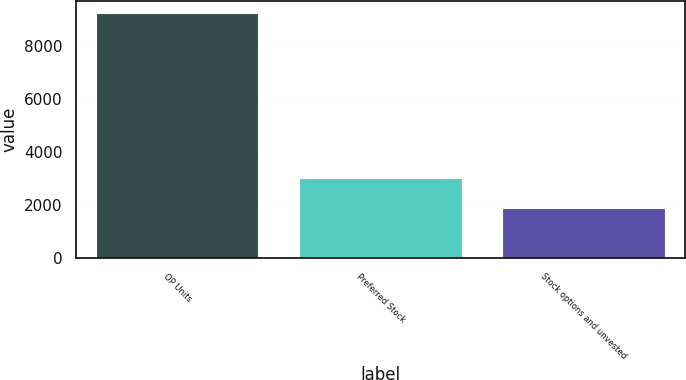Convert chart to OTSL. <chart><loc_0><loc_0><loc_500><loc_500><bar_chart><fcel>OP Units<fcel>Preferred Stock<fcel>Stock options and unvested<nl><fcel>9247<fcel>3036<fcel>1917<nl></chart> 